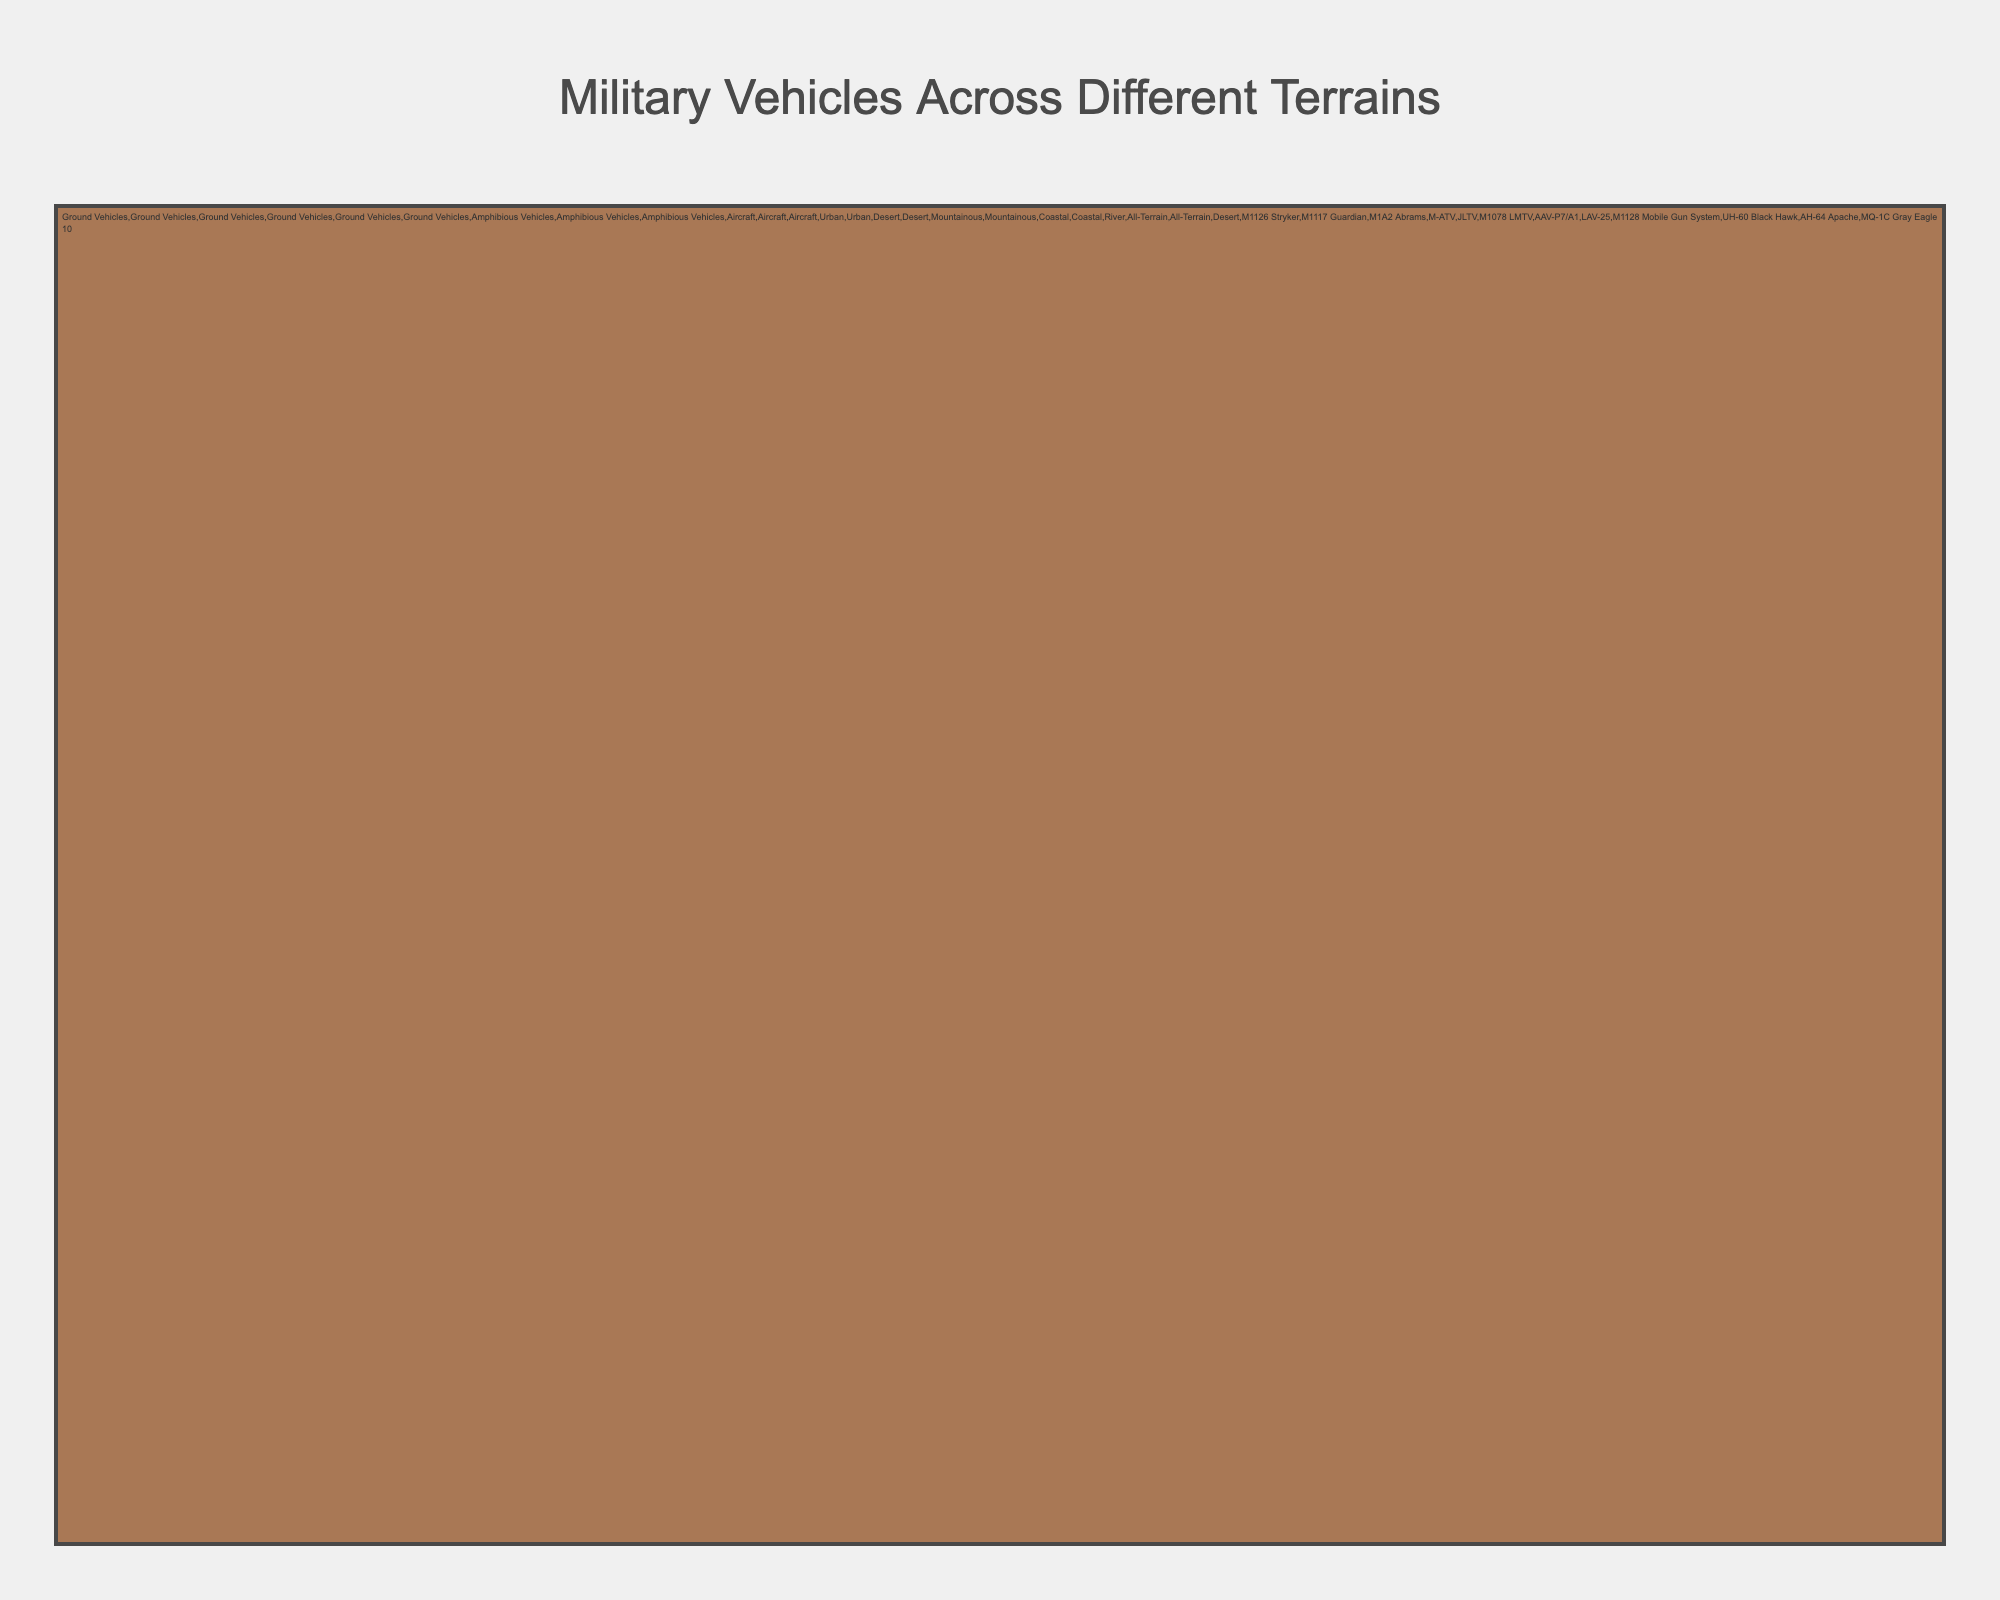How many categories of vehicles are shown in the Icicle Chart? There are four main vehicle categories: Ground Vehicles, Amphibious Vehicles, Aircraft, and the overarching "Vehicle Type". Each category has subcategories but the question focuses only on main categories.
Answer: 3 Which category has the most types of vehicles listed? We count the specific vehicles under each main category: Ground Vehicles (6), Amphibious Vehicles (3), Aircraft (3). Ground Vehicles have the most.
Answer: Ground Vehicles What are the vehicle types designed for urban terrain? Under the "Ground Vehicles" for "Urban" terrain, the specific vehicles listed are M1126 Stryker and M1117 Guardian.
Answer: M1126 Stryker and M1117 Guardian What type of vehicle is used in both Mountainous and Desert terrains? We can see that none of the specific vehicles are listed under both Mountainous and Desert terrains in any category in the chart.
Answer: None How many specific vehicles are used in desert terrain? Under "Ground Vehicles" and "Aircraft" categories for "Desert" terrain, the specific vehicles are M1A2 Abrams, M-ATV, and MQ-1C Gray Eagle. That totals to 3.
Answer: 3 Which terrain has the equal number of vehicles listed compared to Urban terrain? Urban terrain lists 2 vehicles under Ground Vehicles. Coastal terrain under Amphibious Vehicles also lists 2 specific vehicles (AAV-P7/A1 and LAV-25).
Answer: Coastal What is the parent category of the JLTV vehicle? We start from the specific vehicle "JLTV" and trace back to its "Terrain" (Mountainous), and further back to its "Vehicle Type" (Ground Vehicles).
Answer: Ground Vehicles Which vehicle is used in the 'River' terrain? Looking under the "Amphibious Vehicles" for the "River" terrain, M1128 Mobile Gun System is listed.
Answer: M1128 Mobile Gun System 